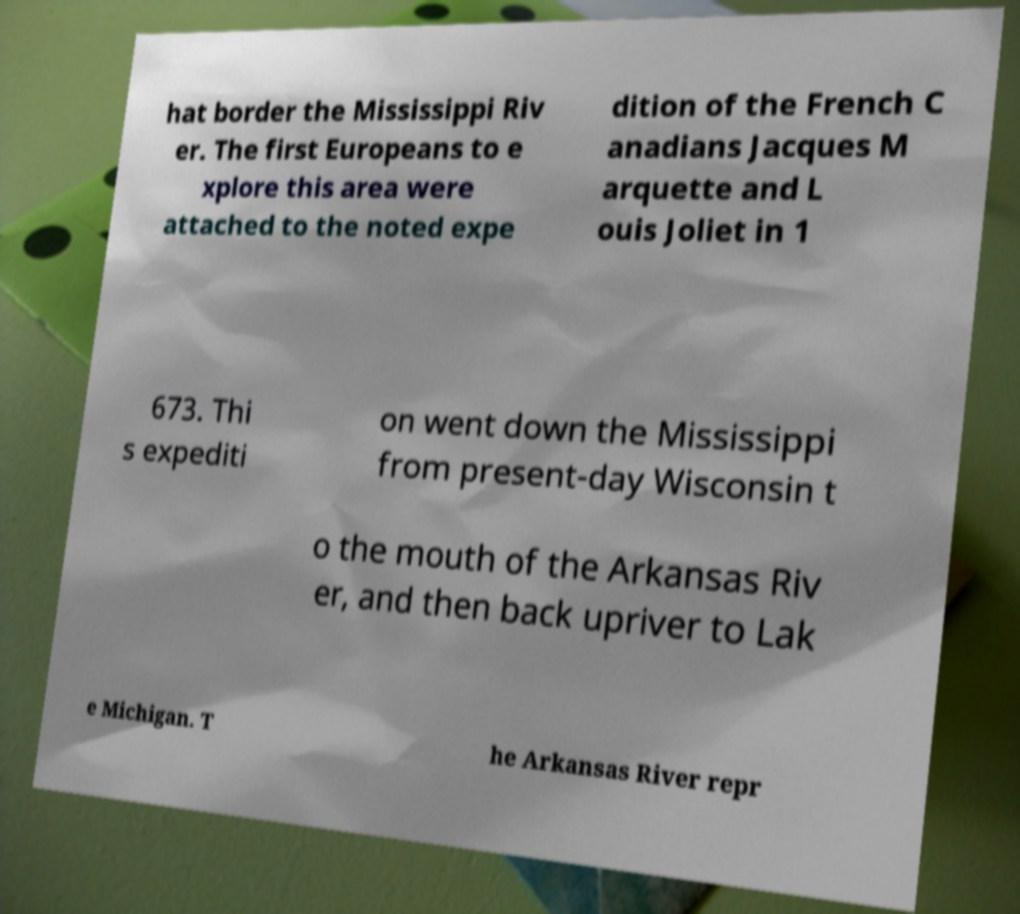I need the written content from this picture converted into text. Can you do that? hat border the Mississippi Riv er. The first Europeans to e xplore this area were attached to the noted expe dition of the French C anadians Jacques M arquette and L ouis Joliet in 1 673. Thi s expediti on went down the Mississippi from present-day Wisconsin t o the mouth of the Arkansas Riv er, and then back upriver to Lak e Michigan. T he Arkansas River repr 